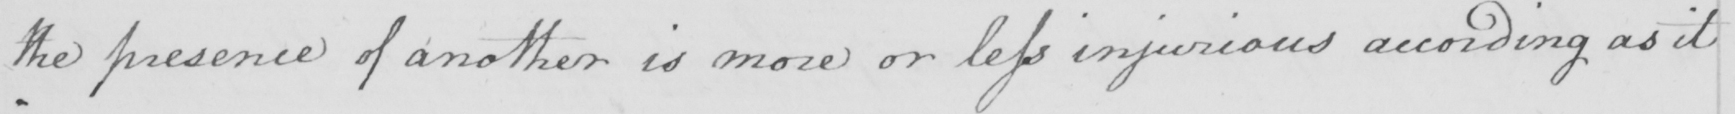Transcribe the text shown in this historical manuscript line. the presence of another is more or less injurious according as it 